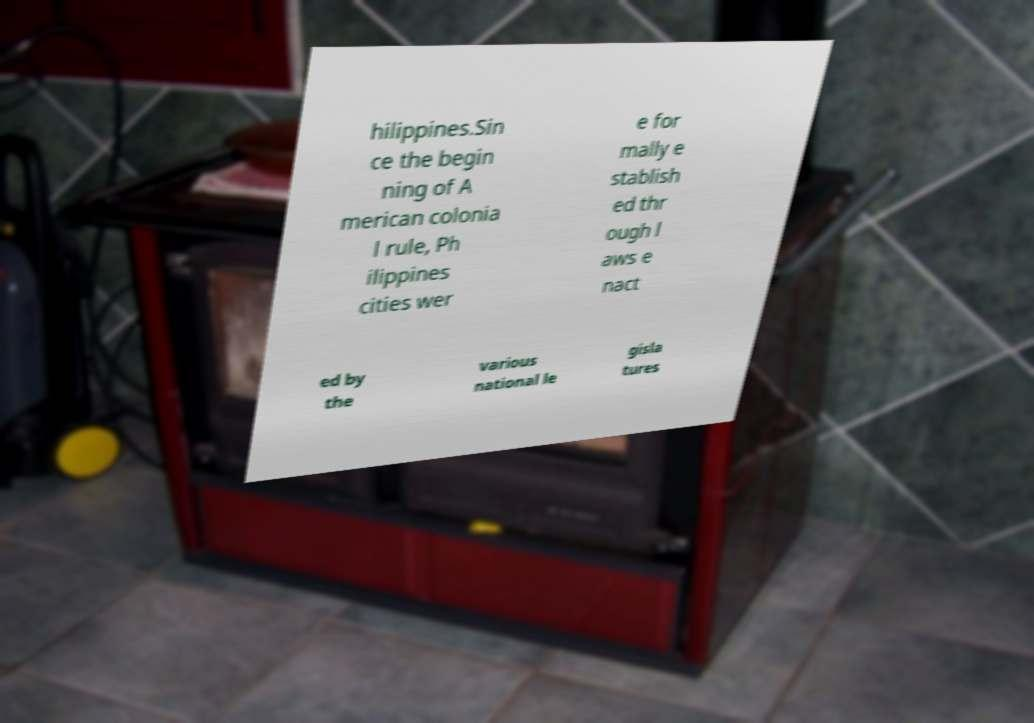What messages or text are displayed in this image? I need them in a readable, typed format. hilippines.Sin ce the begin ning of A merican colonia l rule, Ph ilippines cities wer e for mally e stablish ed thr ough l aws e nact ed by the various national le gisla tures 